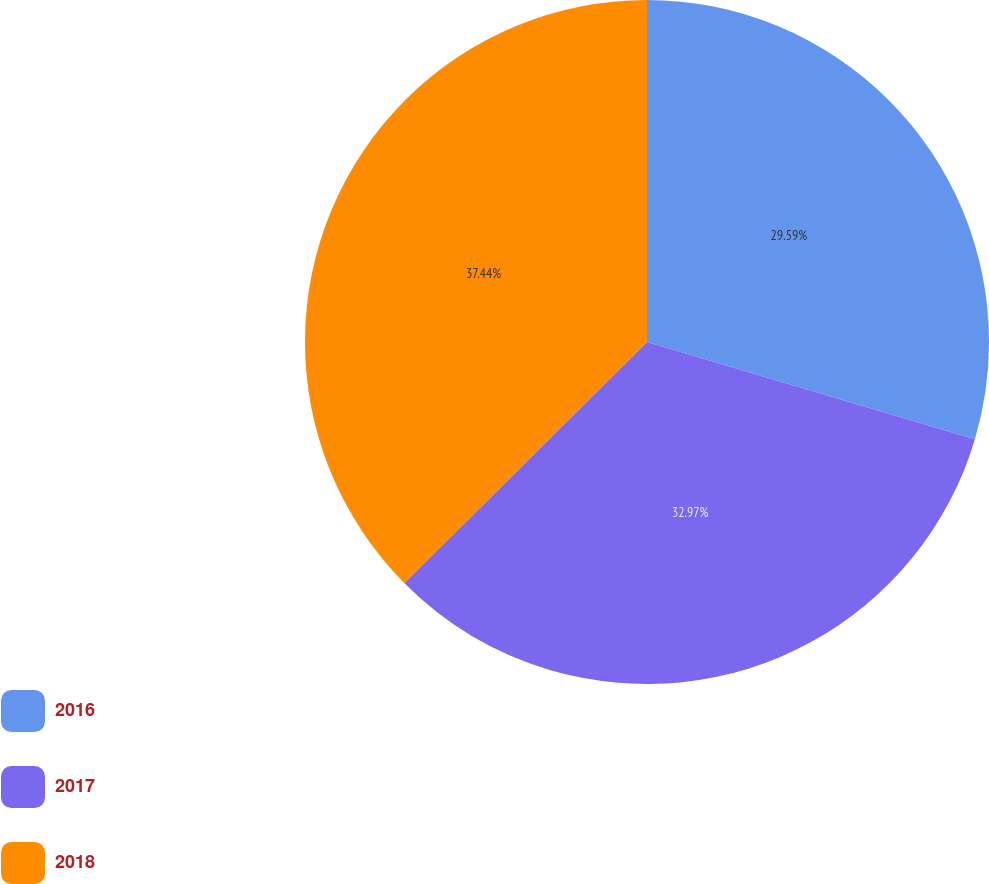<chart> <loc_0><loc_0><loc_500><loc_500><pie_chart><fcel>2016<fcel>2017<fcel>2018<nl><fcel>29.59%<fcel>32.97%<fcel>37.44%<nl></chart> 